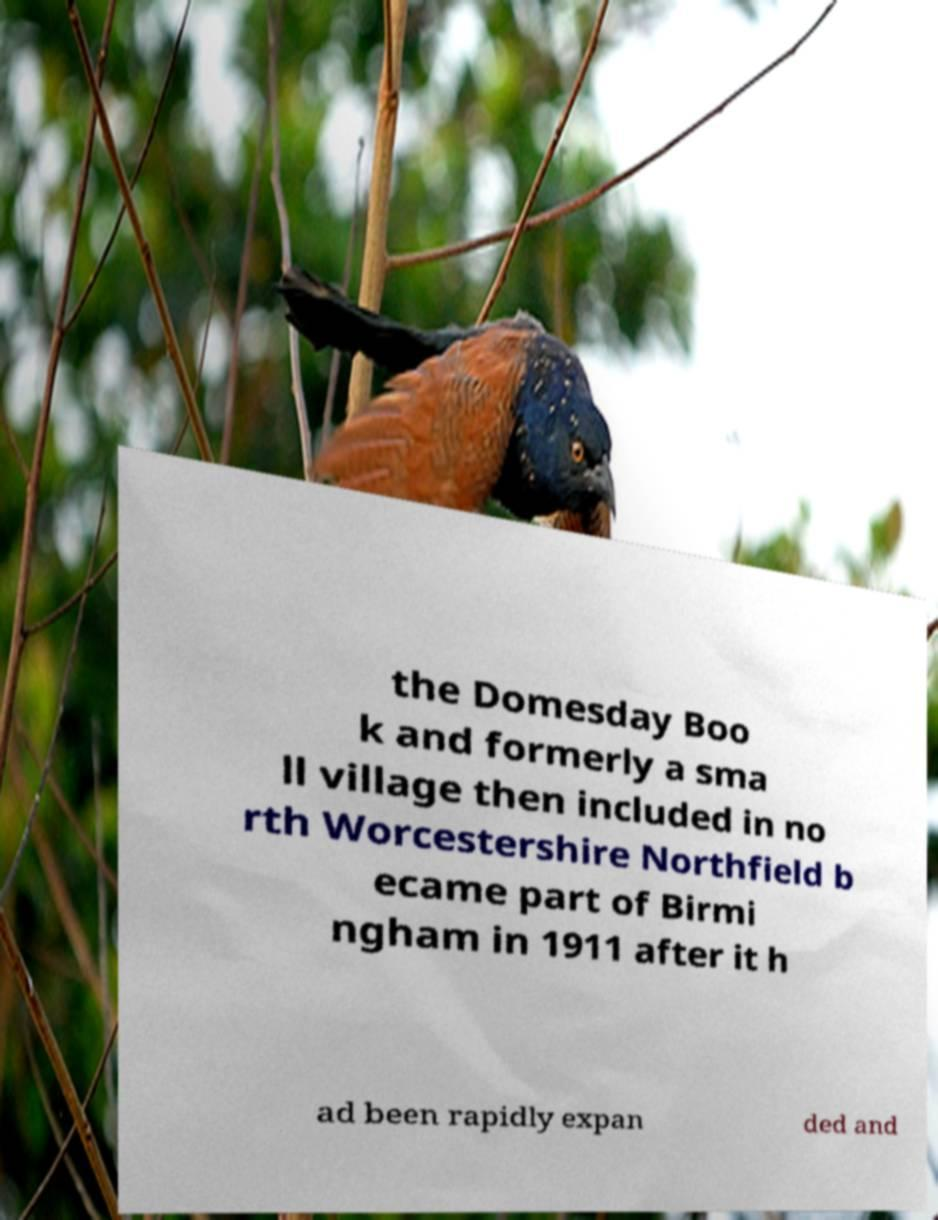For documentation purposes, I need the text within this image transcribed. Could you provide that? the Domesday Boo k and formerly a sma ll village then included in no rth Worcestershire Northfield b ecame part of Birmi ngham in 1911 after it h ad been rapidly expan ded and 